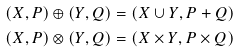<formula> <loc_0><loc_0><loc_500><loc_500>( X , P ) \oplus ( Y , Q ) & = ( X \cup Y , P + Q ) \\ ( X , P ) \otimes ( Y , Q ) & = ( X \times Y , P \times Q )</formula> 